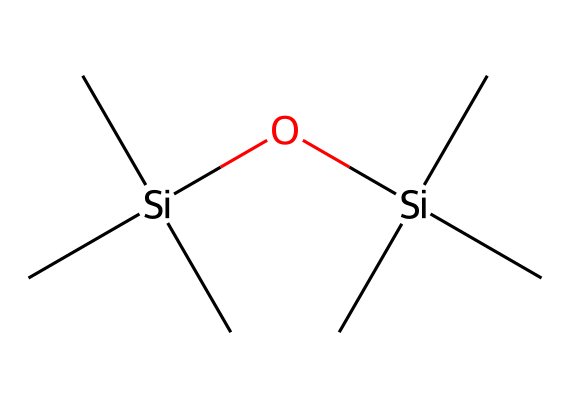What is the primary chemical structure of this compound? The given SMILES representation shows a chemical made up of silicon and oxygen atoms connected by a silicon-oxygen bond, characteristic of siloxanes.
Answer: siloxane How many silicon atoms are present in this chemical? By analyzing the SMILES representation, it can be counted that there are two silicon atoms (Si) as indicated by the two occurrences of the "[Si]" in the structure.
Answer: 2 What is the total number of carbon atoms in this compound? The SMILES representation specifies six carbon (C) atoms that are grouped around the silicon atoms, indicated by the six occurrences of "C".
Answer: 6 How many oxygen atoms does this chemical contain? In the provided SMILES structure, there is one oxygen atom (O) represented by "O", indicating a single occurrence within the compound.
Answer: 1 What type of compound is hexamethyldisiloxane classified as? The presence of the siloxane bond (Si-O-Si) indicates that this compound is a silicone or siloxane compound, as it contains silicon and oxygen atoms in a specific arrangement.
Answer: siloxane What functional group is primarily responsible for the properties of this compound? The functional group that primarily influences the properties of hexamethyldisiloxane is the siloxane group, which consists of silicon-oxygen bonds that confer unique properties like stability and flexibility.
Answer: siloxane group 